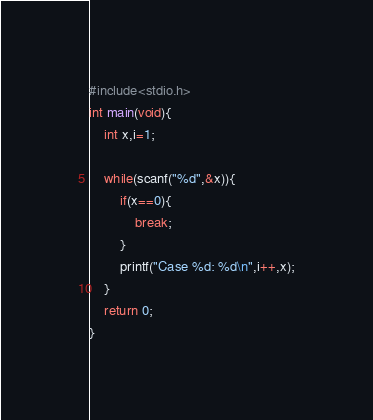Convert code to text. <code><loc_0><loc_0><loc_500><loc_500><_C_>#include<stdio.h>
int main(void){
	int x,i=1;
	
	while(scanf("%d",&x)){
		if(x==0){
			break;
		}
		printf("Case %d: %d\n",i++,x);
	}
	return 0;
}</code> 